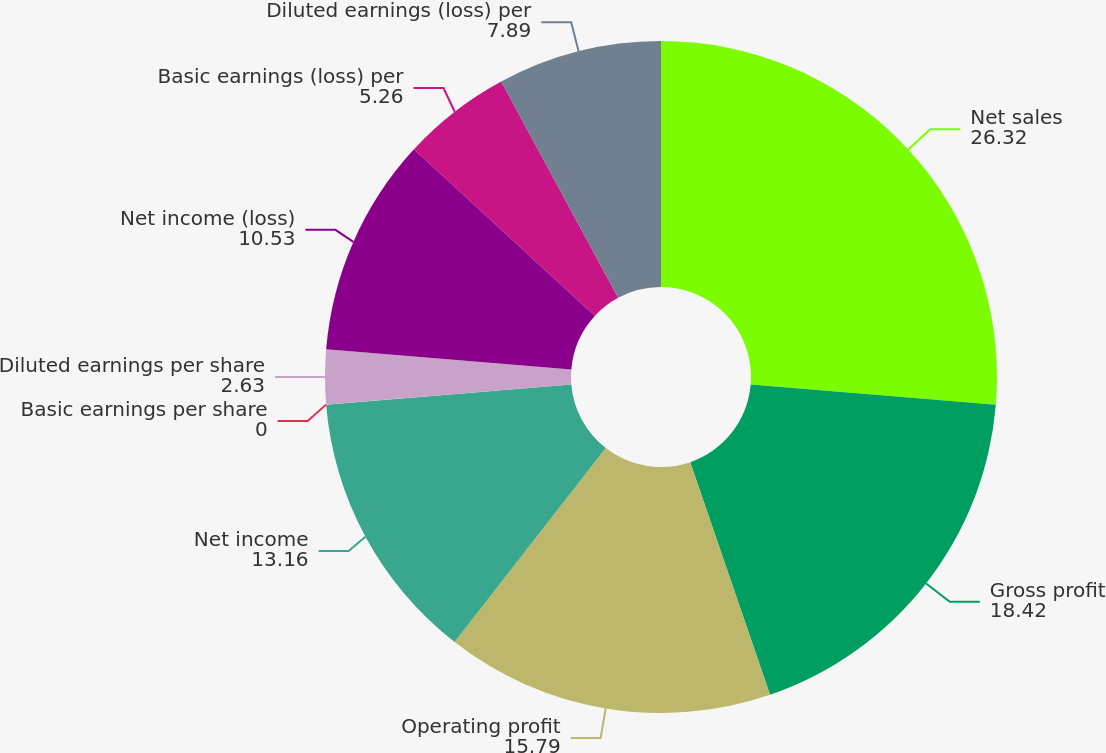Convert chart to OTSL. <chart><loc_0><loc_0><loc_500><loc_500><pie_chart><fcel>Net sales<fcel>Gross profit<fcel>Operating profit<fcel>Net income<fcel>Basic earnings per share<fcel>Diluted earnings per share<fcel>Net income (loss)<fcel>Basic earnings (loss) per<fcel>Diluted earnings (loss) per<nl><fcel>26.32%<fcel>18.42%<fcel>15.79%<fcel>13.16%<fcel>0.0%<fcel>2.63%<fcel>10.53%<fcel>5.26%<fcel>7.89%<nl></chart> 